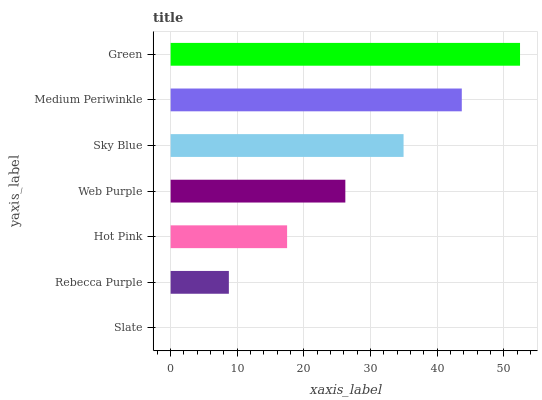Is Slate the minimum?
Answer yes or no. Yes. Is Green the maximum?
Answer yes or no. Yes. Is Rebecca Purple the minimum?
Answer yes or no. No. Is Rebecca Purple the maximum?
Answer yes or no. No. Is Rebecca Purple greater than Slate?
Answer yes or no. Yes. Is Slate less than Rebecca Purple?
Answer yes or no. Yes. Is Slate greater than Rebecca Purple?
Answer yes or no. No. Is Rebecca Purple less than Slate?
Answer yes or no. No. Is Web Purple the high median?
Answer yes or no. Yes. Is Web Purple the low median?
Answer yes or no. Yes. Is Hot Pink the high median?
Answer yes or no. No. Is Green the low median?
Answer yes or no. No. 